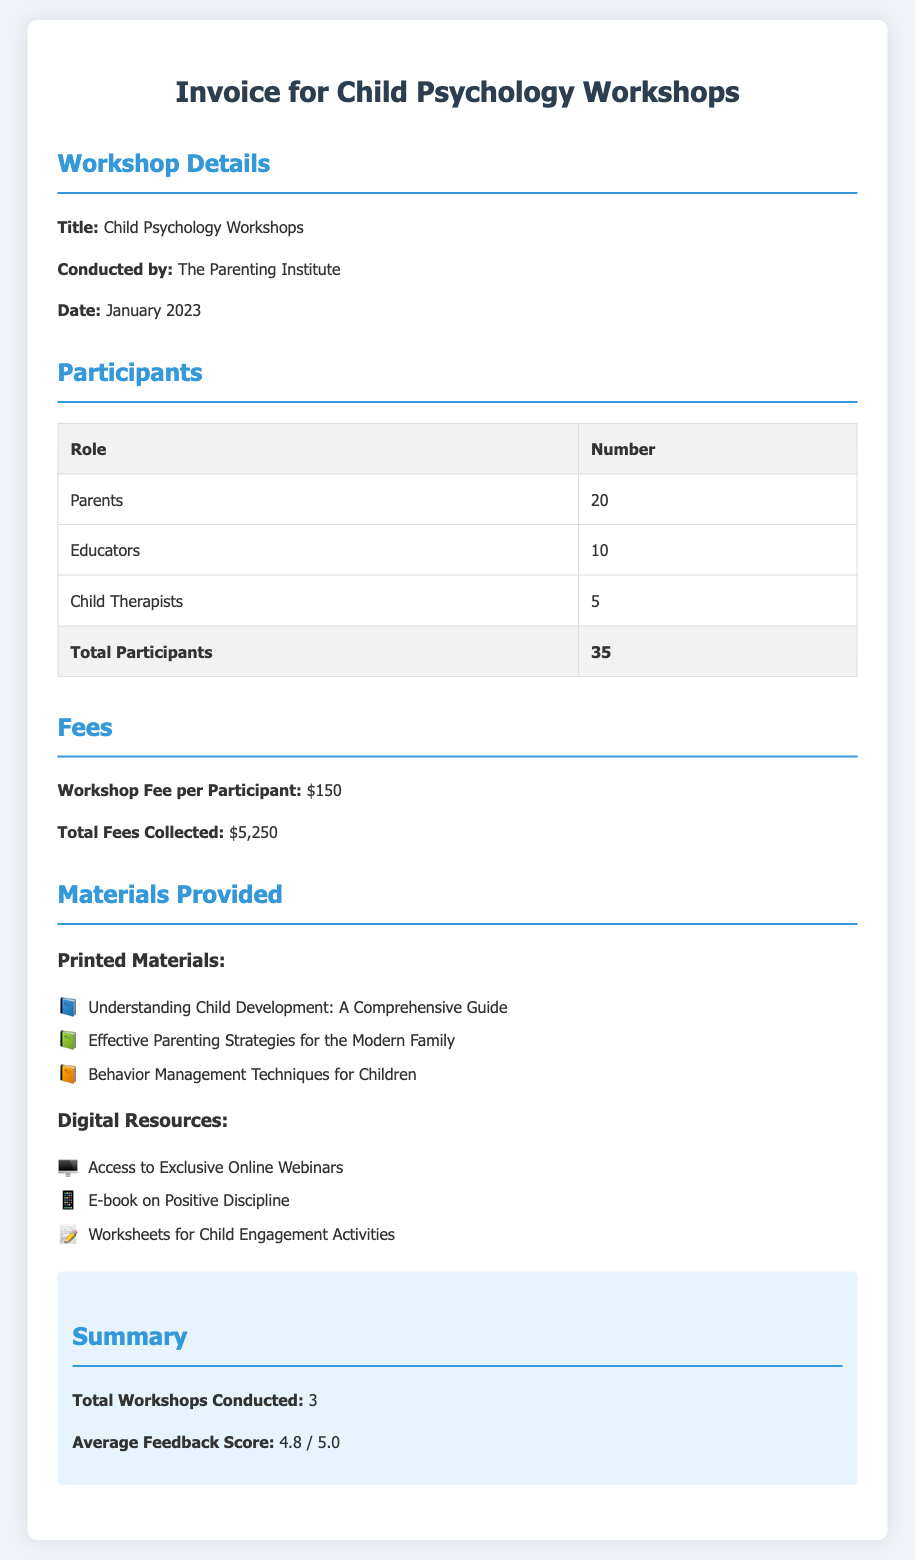What is the title of the workshop? The title of the workshop is specified in the document under the workshop details section.
Answer: Child Psychology Workshops Who conducted the workshop? The entity responsible for conducting the workshop is mentioned in the workshop details.
Answer: The Parenting Institute How many parents participated in the workshop? The document provides a breakdown of participants by role, showing the number of parents.
Answer: 20 What was the total fee collected? The total fees collected are indicated in the fees section of the document.
Answer: $5,250 What materials were provided as printed resources? The document lists the printed materials provided to participants under the materials section.
Answer: Understanding Child Development: A Comprehensive Guide, Effective Parenting Strategies for the Modern Family, Behavior Management Techniques for Children How many total workshops were conducted? The total number of workshops is summarized in the document's summary section.
Answer: 3 What is the average feedback score? The document includes a specific section summarizing the average feedback score received.
Answer: 4.8 / 5.0 How many educators participated in the workshop? The document contains a participant breakdown, revealing the number of educators involved.
Answer: 10 What type of digital resource was provided? The types of digital resources offered are specified in the materials section of the document.
Answer: Access to Exclusive Online Webinars 